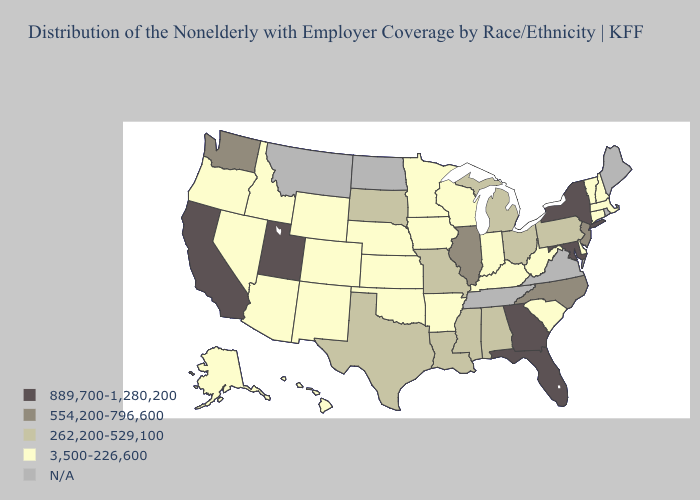What is the highest value in states that border Utah?
Be succinct. 3,500-226,600. Does Alabama have the lowest value in the South?
Be succinct. No. What is the highest value in states that border New Hampshire?
Short answer required. 3,500-226,600. What is the value of New Mexico?
Give a very brief answer. 3,500-226,600. Name the states that have a value in the range N/A?
Short answer required. Maine, Montana, North Dakota, Rhode Island, Tennessee, Virginia. Does New York have the highest value in the USA?
Short answer required. Yes. Does the first symbol in the legend represent the smallest category?
Quick response, please. No. Name the states that have a value in the range 3,500-226,600?
Concise answer only. Alaska, Arizona, Arkansas, Colorado, Connecticut, Delaware, Hawaii, Idaho, Indiana, Iowa, Kansas, Kentucky, Massachusetts, Minnesota, Nebraska, Nevada, New Hampshire, New Mexico, Oklahoma, Oregon, South Carolina, Vermont, West Virginia, Wisconsin, Wyoming. What is the highest value in states that border Nevada?
Concise answer only. 889,700-1,280,200. Does Pennsylvania have the lowest value in the Northeast?
Give a very brief answer. No. Does Florida have the highest value in the USA?
Quick response, please. Yes. What is the value of Tennessee?
Keep it brief. N/A. Name the states that have a value in the range 889,700-1,280,200?
Keep it brief. California, Florida, Georgia, Maryland, New York, Utah. What is the value of Florida?
Keep it brief. 889,700-1,280,200. 